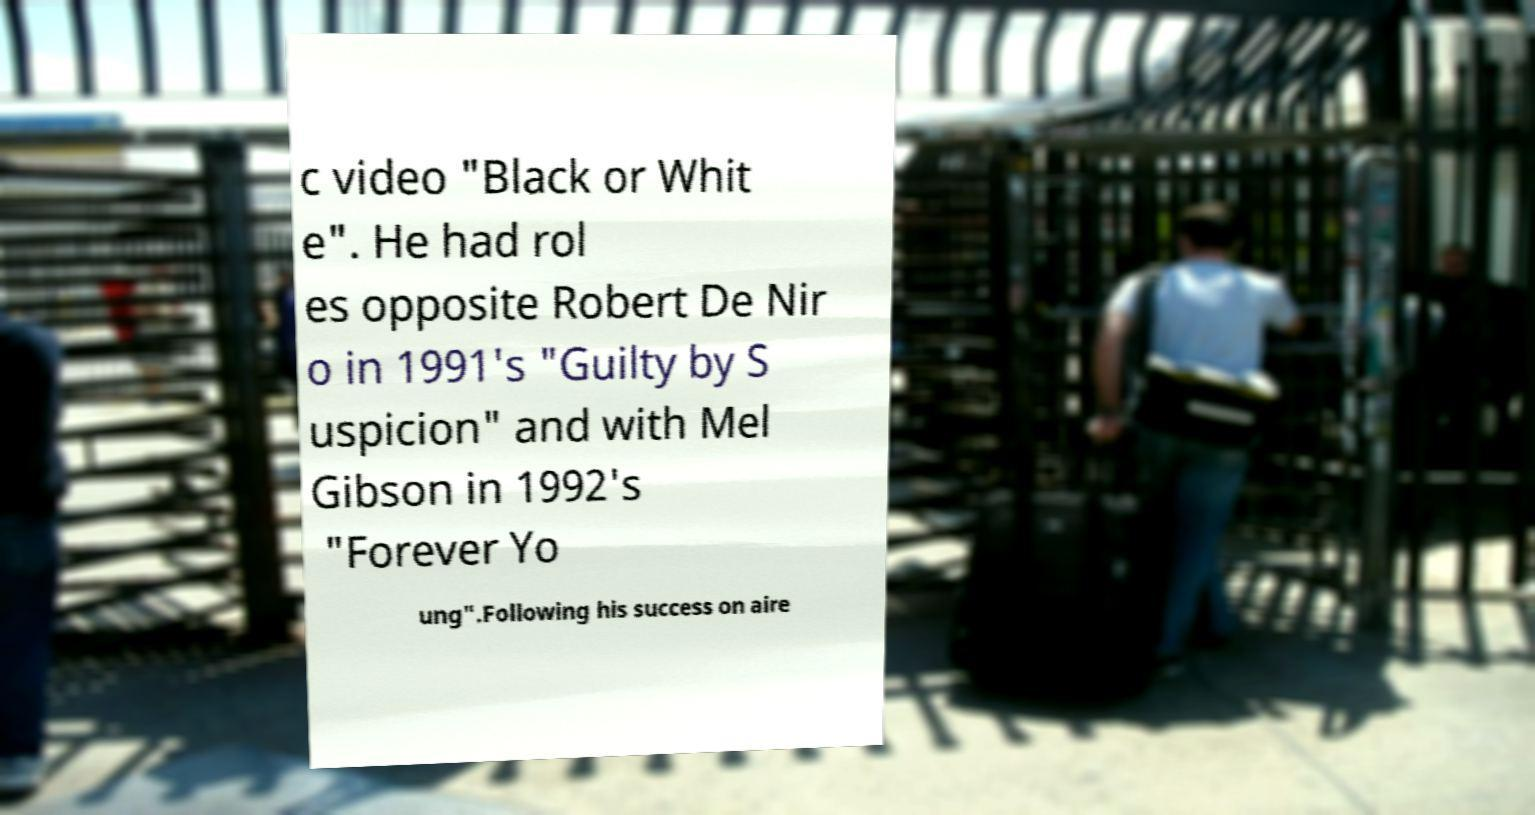Can you read and provide the text displayed in the image?This photo seems to have some interesting text. Can you extract and type it out for me? c video "Black or Whit e". He had rol es opposite Robert De Nir o in 1991's "Guilty by S uspicion" and with Mel Gibson in 1992's "Forever Yo ung".Following his success on aire 